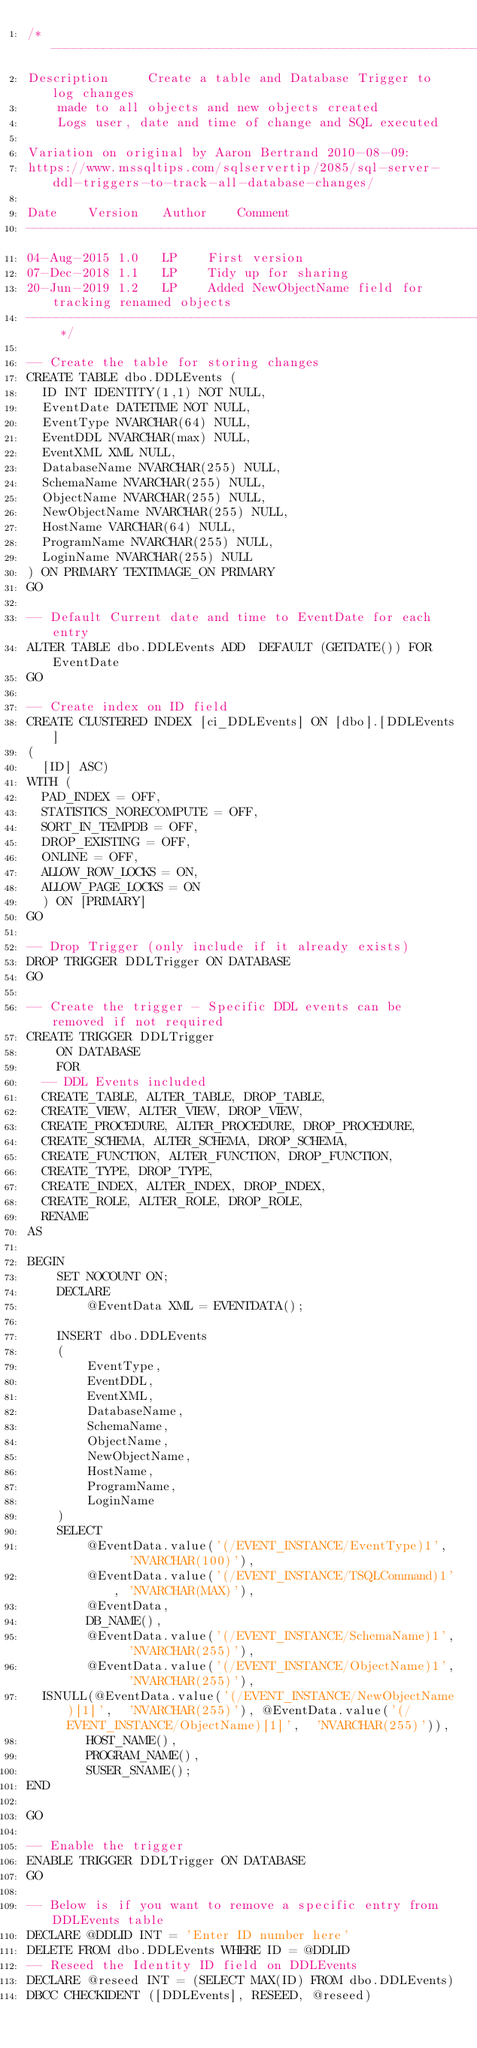Convert code to text. <code><loc_0><loc_0><loc_500><loc_500><_SQL_>/*------------------------------------------------------------------------------------------------------ 
Description   	Create a table and Database Trigger to log changes 
		made to all objects and new objects created
		Logs user, date and time of change and SQL executed

Variation on original by Aaron Bertrand 2010-08-09:
https://www.mssqltips.com/sqlservertip/2085/sql-server-ddl-triggers-to-track-all-database-changes/
                 
Date		Version		Author		Comment
---------------------------------------------------------------------------------------------------------
04-Aug-2015	1.0		LP		First version
07-Dec-2018	1.1		LP		Tidy up for sharing
20-Jun-2019	1.2		LP		Added NewObjectName field for tracking renamed objects
--------------------------------------------------------------------------------------------------------- */

-- Create the table for storing changes
CREATE TABLE dbo.DDLEvents (
	ID INT IDENTITY(1,1) NOT NULL,
	EventDate DATETIME NOT NULL,
	EventType NVARCHAR(64) NULL,
	EventDDL NVARCHAR(max) NULL,
	EventXML XML NULL,
	DatabaseName NVARCHAR(255) NULL,
	SchemaName NVARCHAR(255) NULL,
	ObjectName NVARCHAR(255) NULL,
	NewObjectName NVARCHAR(255) NULL,
	HostName VARCHAR(64) NULL,
	ProgramName NVARCHAR(255) NULL,
	LoginName NVARCHAR(255) NULL
) ON PRIMARY TEXTIMAGE_ON PRIMARY
GO

-- Default Current date and time to EventDate for each entry
ALTER TABLE dbo.DDLEvents ADD  DEFAULT (GETDATE()) FOR EventDate
GO

-- Create index on ID field
CREATE CLUSTERED INDEX [ci_DDLEvents] ON [dbo].[DDLEvents]
(
	[ID] ASC)
WITH (
	PAD_INDEX = OFF, 
	STATISTICS_NORECOMPUTE = OFF, 
	SORT_IN_TEMPDB = OFF, 
	DROP_EXISTING = OFF, 
	ONLINE = OFF, 
	ALLOW_ROW_LOCKS = ON, 
	ALLOW_PAGE_LOCKS = ON
	) ON [PRIMARY]
GO

-- Drop Trigger (only include if it already exists)
DROP TRIGGER DDLTrigger ON DATABASE
GO

-- Create the trigger - Specific DDL events can be removed if not required
CREATE TRIGGER DDLTrigger
    ON DATABASE
    FOR
	-- DDL Events included
	CREATE_TABLE, ALTER_TABLE, DROP_TABLE, 
	CREATE_VIEW, ALTER_VIEW, DROP_VIEW, 
	CREATE_PROCEDURE, ALTER_PROCEDURE, DROP_PROCEDURE, 
	CREATE_SCHEMA, ALTER_SCHEMA, DROP_SCHEMA,
	CREATE_FUNCTION, ALTER_FUNCTION, DROP_FUNCTION,
	CREATE_TYPE, DROP_TYPE,
	CREATE_INDEX, ALTER_INDEX, DROP_INDEX,
	CREATE_ROLE, ALTER_ROLE, DROP_ROLE,
	RENAME
AS

BEGIN
    SET NOCOUNT ON;
    DECLARE
        @EventData XML = EVENTDATA();
 
    INSERT dbo.DDLEvents
    (
        EventType,
        EventDDL,
        EventXML,
        DatabaseName,
        SchemaName,
        ObjectName,
        NewObjectName,
        HostName,
        ProgramName,
        LoginName
    )
    SELECT
        @EventData.value('(/EVENT_INSTANCE/EventType)1',   'NVARCHAR(100)'), 
        @EventData.value('(/EVENT_INSTANCE/TSQLCommand)1', 'NVARCHAR(MAX)'),
        @EventData,
        DB_NAME(),
        @EventData.value('(/EVENT_INSTANCE/SchemaName)1',  'NVARCHAR(255)'), 
        @EventData.value('(/EVENT_INSTANCE/ObjectName)1',  'NVARCHAR(255)'),
	ISNULL(@EventData.value('(/EVENT_INSTANCE/NewObjectName)[1]',  'NVARCHAR(255)'), @EventData.value('(/EVENT_INSTANCE/ObjectName)[1]',  'NVARCHAR(255)')),
        HOST_NAME(),
        PROGRAM_NAME(),
        SUSER_SNAME();
END

GO

-- Enable the trigger
ENABLE TRIGGER DDLTrigger ON DATABASE
GO

-- Below is if you want to remove a specific entry from DDLEvents table
DECLARE @DDLID INT = 'Enter ID number here'
DELETE FROM dbo.DDLEvents WHERE ID = @DDLID
-- Reseed the Identity ID field on DDLEvents
DECLARE @reseed INT = (SELECT MAX(ID) FROM dbo.DDLEvents)
DBCC CHECKIDENT ([DDLEvents], RESEED, @reseed)
</code> 